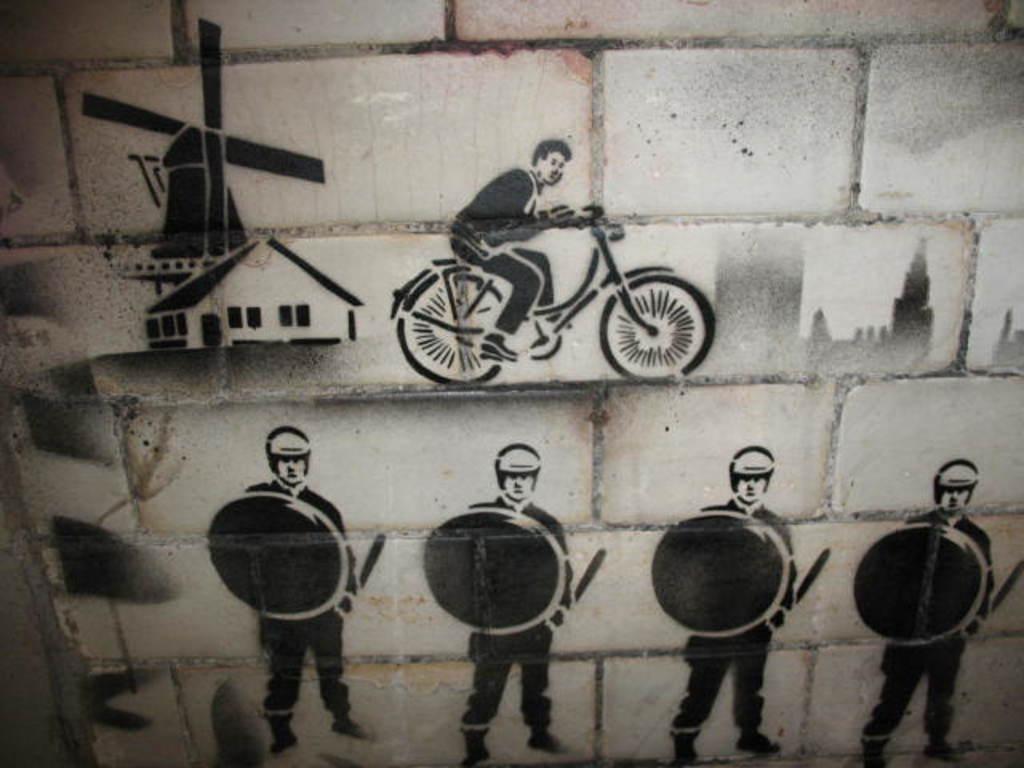Describe this image in one or two sentences. In this image we can see the wall and on the wall we can see the sketches of a house and also the people and a person with the vehicle. 